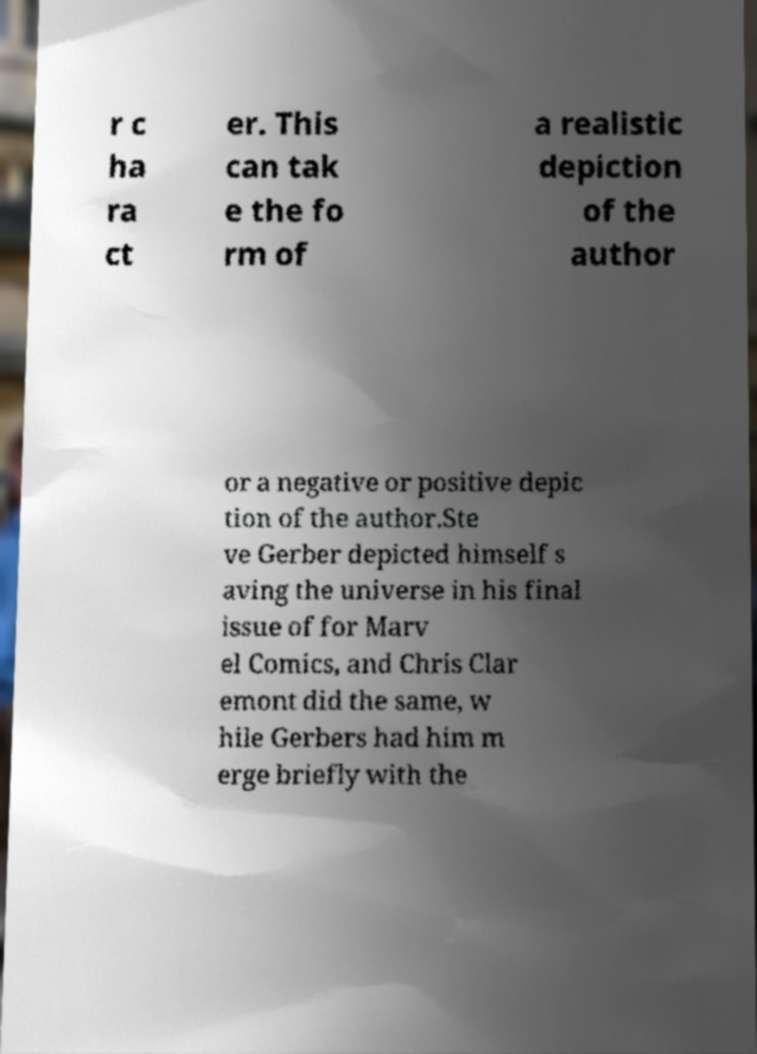I need the written content from this picture converted into text. Can you do that? r c ha ra ct er. This can tak e the fo rm of a realistic depiction of the author or a negative or positive depic tion of the author.Ste ve Gerber depicted himself s aving the universe in his final issue of for Marv el Comics, and Chris Clar emont did the same, w hile Gerbers had him m erge briefly with the 